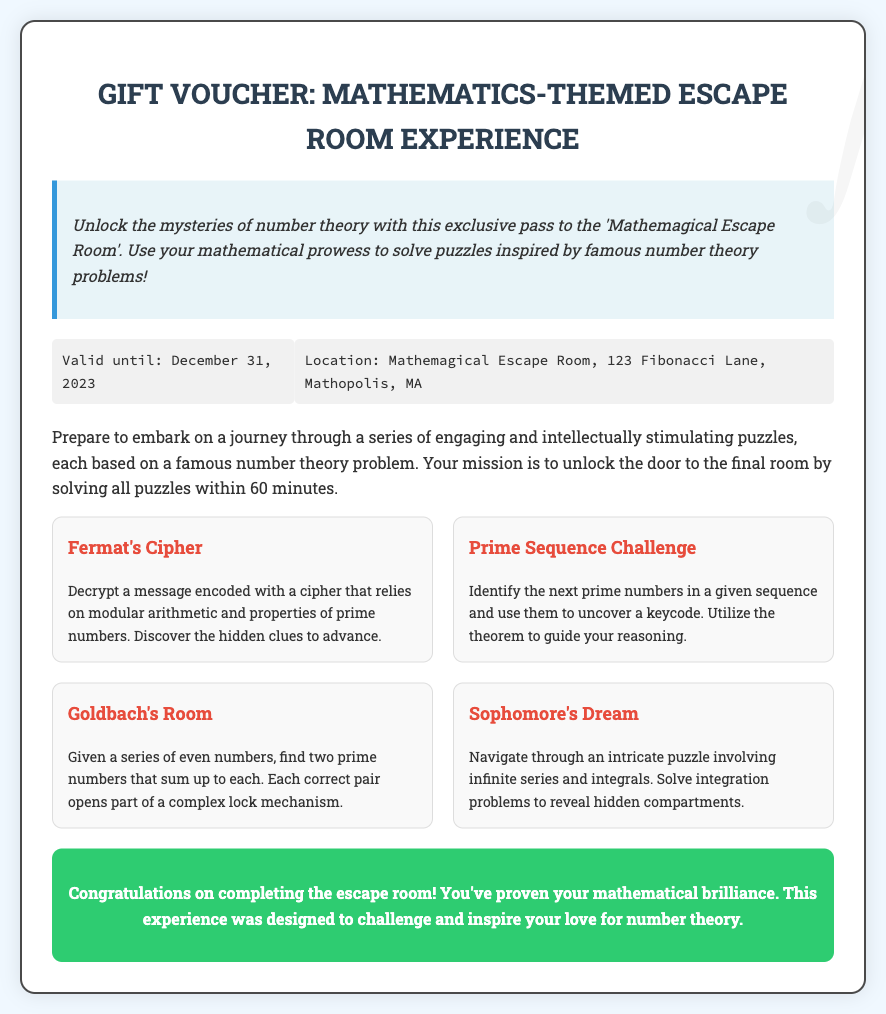What is the title of the voucher? The title of the voucher is prominently displayed at the top of the document, which is "Gift Voucher: Mathematics-Themed Escape Room Experience."
Answer: Gift Voucher: Mathematics-Themed Escape Room Experience What is the validity date of the voucher? The validity date of the voucher is mentioned in the details section of the document.
Answer: December 31, 2023 Where is the escape room located? The location of the escape room is provided in the details section as "Mathemagical Escape Room, 123 Fibonacci Lane, Mathopolis, MA."
Answer: Mathemagical Escape Room, 123 Fibonacci Lane, Mathopolis, MA What is the maximum duration for solving the puzzles in the escape room? The document states that the mission is to unlock the door to the final room by solving all puzzles within 60 minutes.
Answer: 60 minutes Which famous number theory problem is associated with the puzzle "Goldbach's Room"? The puzzle description specifically mentions "Goldbach's room" as related to a theorem involving prime numbers summing to even numbers.
Answer: Goldbach's Conjecture How many puzzles are described in the voucher? The voucher lists a total of four distinct puzzles related to number theory.
Answer: Four What theme is centered around the escape room experience? The theme is based on mathematical concepts, specifically number theory.
Answer: Number theory What message is provided in the message section? The message section emphasizes unlocking mysteries of number theory through solving puzzles in the escape room.
Answer: Unlock the mysteries of number theory with this exclusive pass to the 'Mathemagical Escape Room' What is the color of the conclusion section? The conclusion section is described as having a background color of green.
Answer: Green 